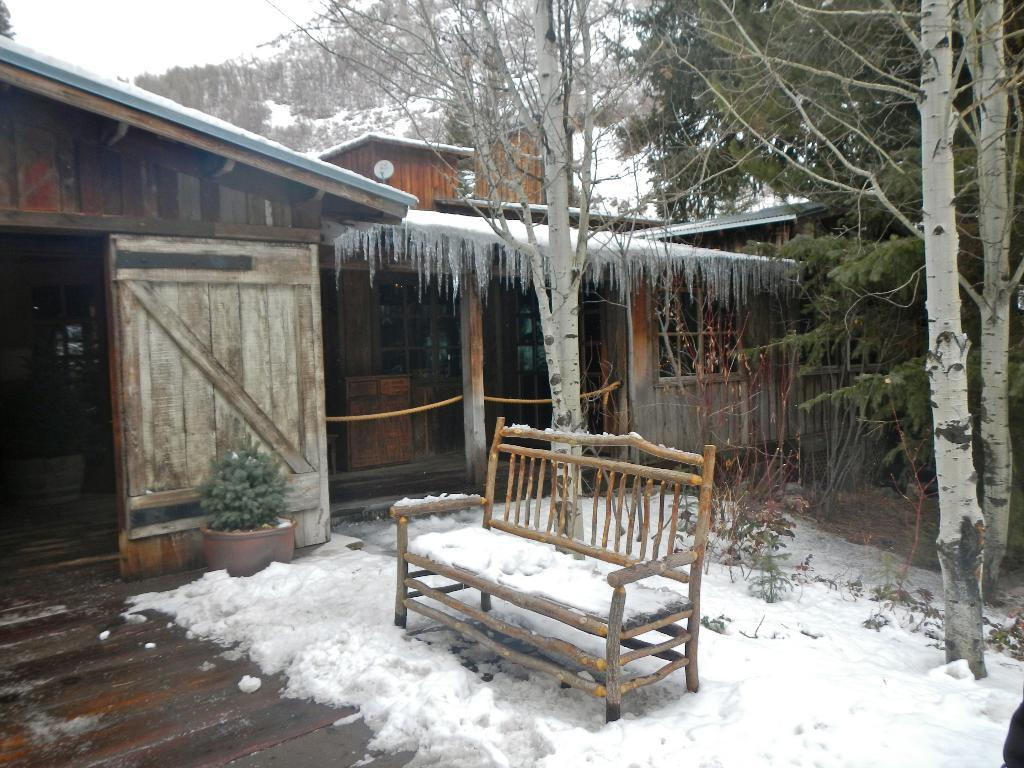What is covering the ground in the foreground of the image? There is snow in the foreground of the image. What object is located in the foreground of the image? There is a bench in the foreground of the image. What can be seen in the background of the image? There are houses, trees, flower pots, and snow mountains in the background of the image. What type of star can be seen shining brightly in the image? There is no star visible in the image; it is set in a snowy landscape. Can you tell me how many zippers are present on the flower pots in the image? There are no zippers present on the flower pots in the image; they are made of pottery or another material. 